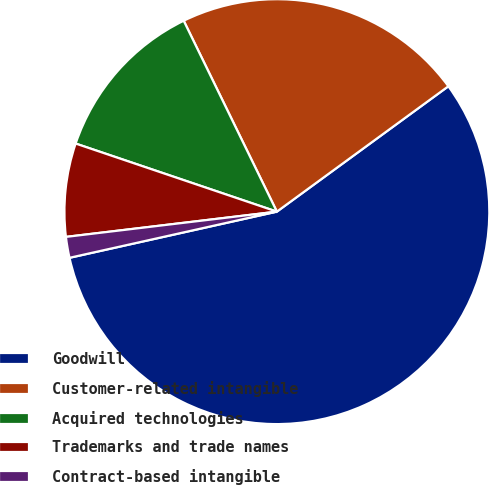<chart> <loc_0><loc_0><loc_500><loc_500><pie_chart><fcel>Goodwill<fcel>Customer-related intangible<fcel>Acquired technologies<fcel>Trademarks and trade names<fcel>Contract-based intangible<nl><fcel>56.56%<fcel>22.18%<fcel>12.58%<fcel>7.09%<fcel>1.59%<nl></chart> 